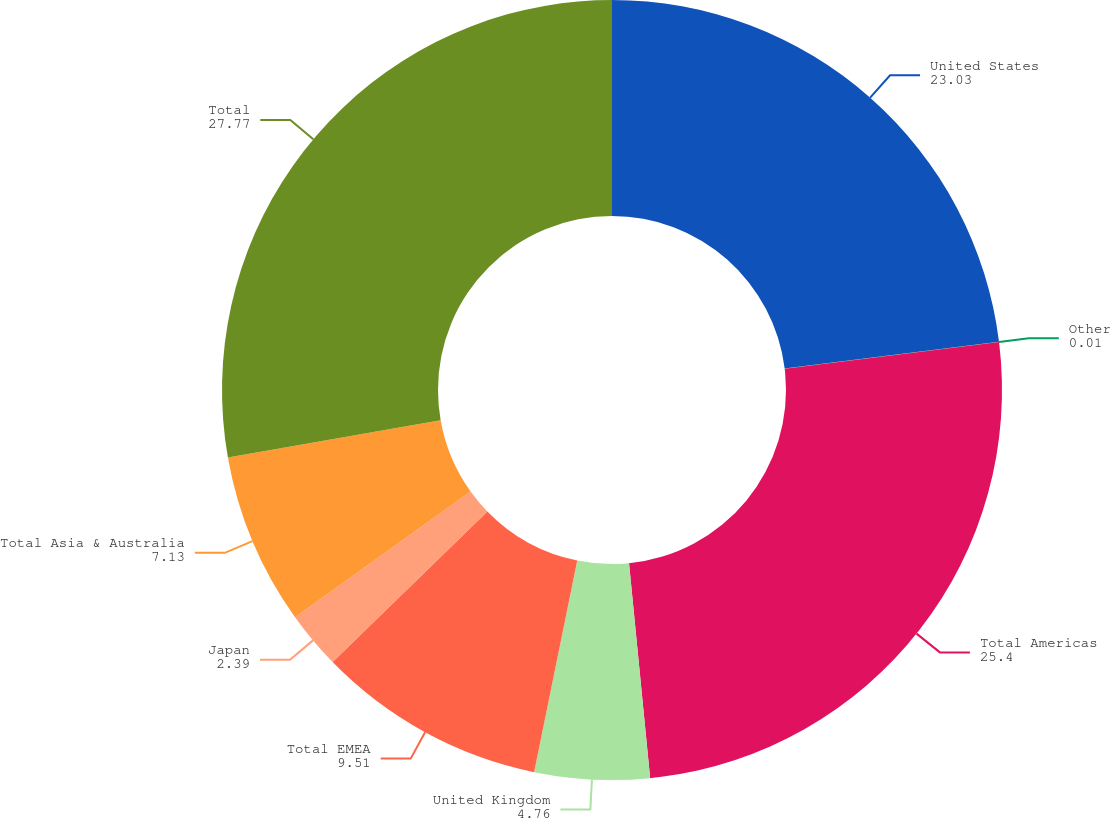Convert chart to OTSL. <chart><loc_0><loc_0><loc_500><loc_500><pie_chart><fcel>United States<fcel>Other<fcel>Total Americas<fcel>United Kingdom<fcel>Total EMEA<fcel>Japan<fcel>Total Asia & Australia<fcel>Total<nl><fcel>23.03%<fcel>0.01%<fcel>25.4%<fcel>4.76%<fcel>9.51%<fcel>2.39%<fcel>7.13%<fcel>27.77%<nl></chart> 